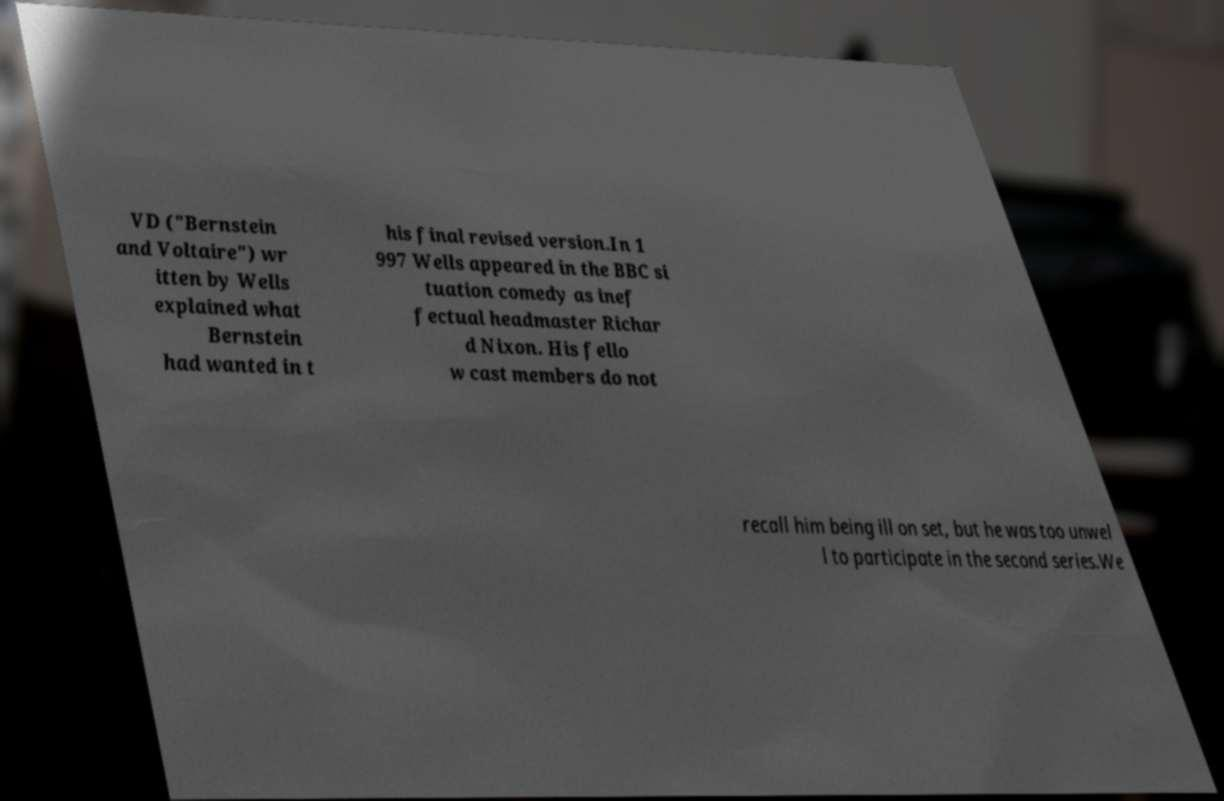I need the written content from this picture converted into text. Can you do that? VD ("Bernstein and Voltaire") wr itten by Wells explained what Bernstein had wanted in t his final revised version.In 1 997 Wells appeared in the BBC si tuation comedy as inef fectual headmaster Richar d Nixon. His fello w cast members do not recall him being ill on set, but he was too unwel l to participate in the second series.We 